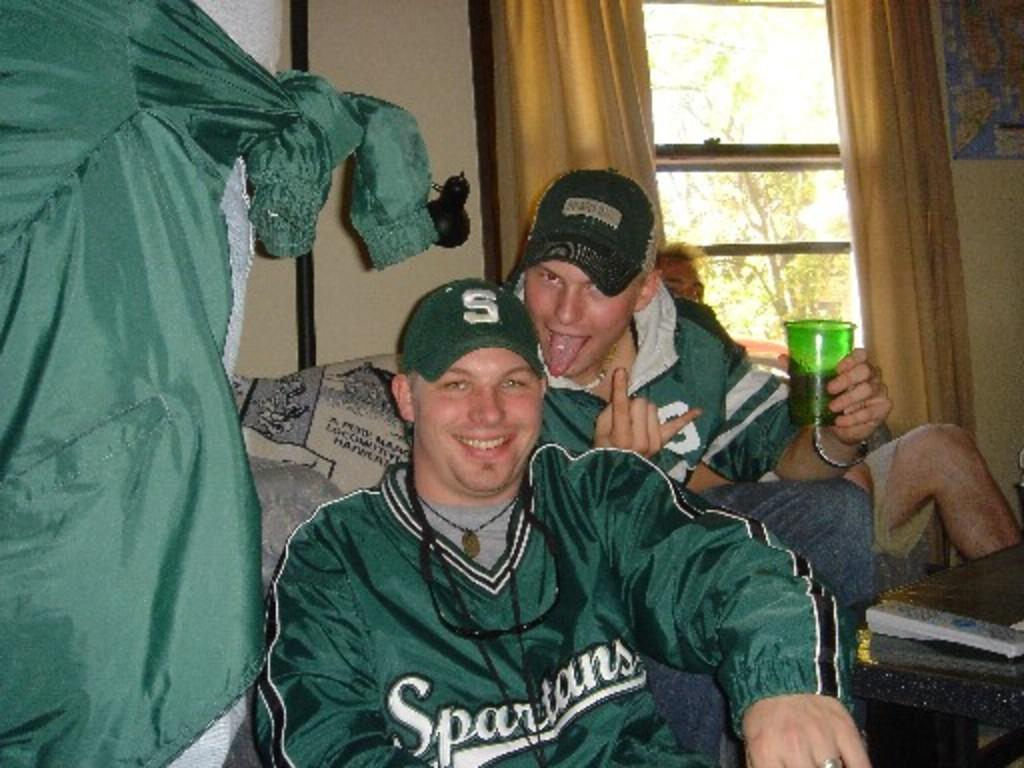<image>
Relay a brief, clear account of the picture shown. Spartan fans all in green are smiling and partying. 